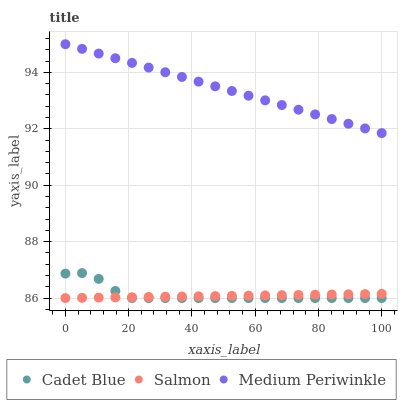Does Salmon have the minimum area under the curve?
Answer yes or no. Yes. Does Medium Periwinkle have the maximum area under the curve?
Answer yes or no. Yes. Does Cadet Blue have the minimum area under the curve?
Answer yes or no. No. Does Cadet Blue have the maximum area under the curve?
Answer yes or no. No. Is Medium Periwinkle the smoothest?
Answer yes or no. Yes. Is Cadet Blue the roughest?
Answer yes or no. Yes. Is Salmon the smoothest?
Answer yes or no. No. Is Salmon the roughest?
Answer yes or no. No. Does Cadet Blue have the lowest value?
Answer yes or no. Yes. Does Medium Periwinkle have the highest value?
Answer yes or no. Yes. Does Cadet Blue have the highest value?
Answer yes or no. No. Is Cadet Blue less than Medium Periwinkle?
Answer yes or no. Yes. Is Medium Periwinkle greater than Salmon?
Answer yes or no. Yes. Does Cadet Blue intersect Salmon?
Answer yes or no. Yes. Is Cadet Blue less than Salmon?
Answer yes or no. No. Is Cadet Blue greater than Salmon?
Answer yes or no. No. Does Cadet Blue intersect Medium Periwinkle?
Answer yes or no. No. 